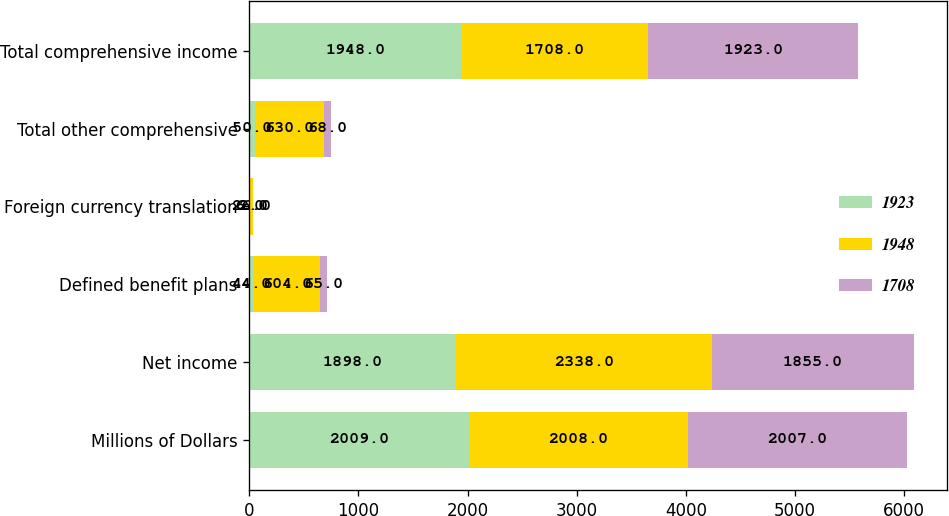Convert chart. <chart><loc_0><loc_0><loc_500><loc_500><stacked_bar_chart><ecel><fcel>Millions of Dollars<fcel>Net income<fcel>Defined benefit plans<fcel>Foreign currency translation<fcel>Total other comprehensive<fcel>Total comprehensive income<nl><fcel>1923<fcel>2009<fcel>1898<fcel>44<fcel>6<fcel>50<fcel>1948<nl><fcel>1948<fcel>2008<fcel>2338<fcel>604<fcel>26<fcel>630<fcel>1708<nl><fcel>1708<fcel>2007<fcel>1855<fcel>65<fcel>2<fcel>68<fcel>1923<nl></chart> 